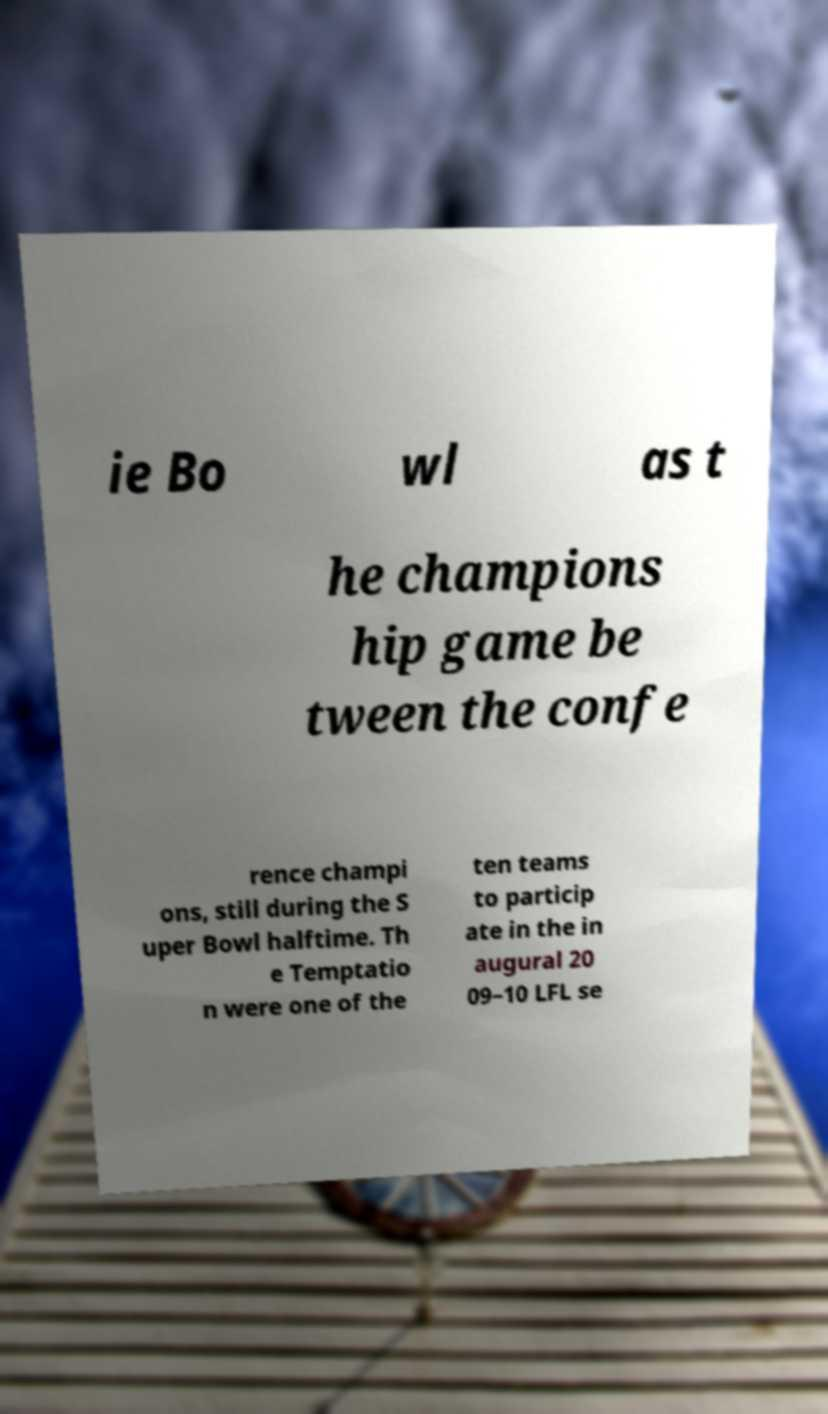Please identify and transcribe the text found in this image. ie Bo wl as t he champions hip game be tween the confe rence champi ons, still during the S uper Bowl halftime. Th e Temptatio n were one of the ten teams to particip ate in the in augural 20 09–10 LFL se 